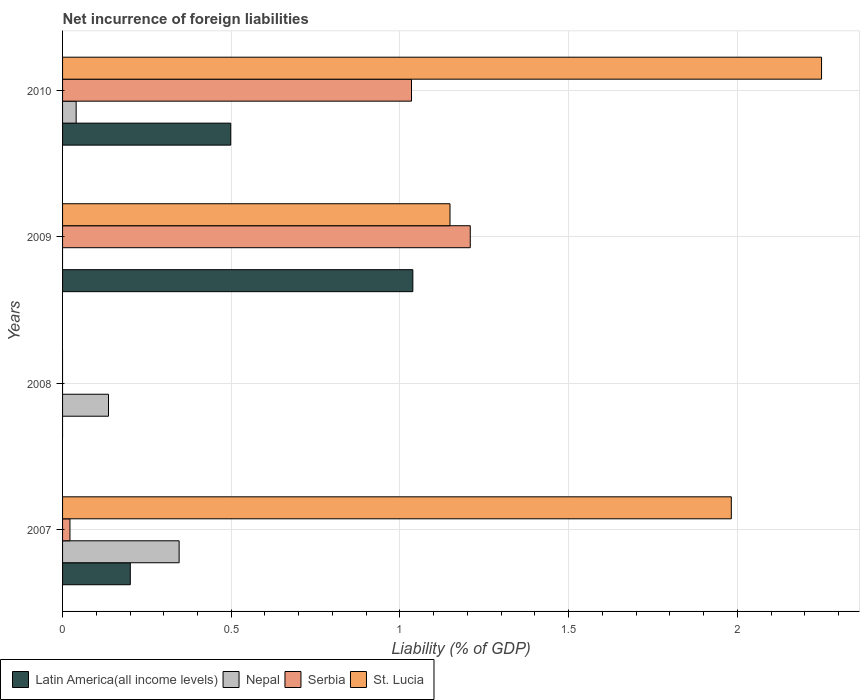Are the number of bars on each tick of the Y-axis equal?
Provide a succinct answer. No. What is the label of the 2nd group of bars from the top?
Your answer should be very brief. 2009. What is the net incurrence of foreign liabilities in Serbia in 2010?
Your answer should be compact. 1.03. Across all years, what is the maximum net incurrence of foreign liabilities in Nepal?
Give a very brief answer. 0.35. What is the total net incurrence of foreign liabilities in Nepal in the graph?
Ensure brevity in your answer.  0.52. What is the difference between the net incurrence of foreign liabilities in St. Lucia in 2007 and that in 2009?
Your answer should be compact. 0.83. What is the difference between the net incurrence of foreign liabilities in Nepal in 2009 and the net incurrence of foreign liabilities in Serbia in 2007?
Give a very brief answer. -0.02. What is the average net incurrence of foreign liabilities in Serbia per year?
Provide a short and direct response. 0.57. In the year 2007, what is the difference between the net incurrence of foreign liabilities in Serbia and net incurrence of foreign liabilities in St. Lucia?
Offer a very short reply. -1.96. In how many years, is the net incurrence of foreign liabilities in Nepal greater than 0.6 %?
Offer a terse response. 0. Is the difference between the net incurrence of foreign liabilities in Serbia in 2007 and 2010 greater than the difference between the net incurrence of foreign liabilities in St. Lucia in 2007 and 2010?
Keep it short and to the point. No. What is the difference between the highest and the second highest net incurrence of foreign liabilities in Serbia?
Your response must be concise. 0.17. What is the difference between the highest and the lowest net incurrence of foreign liabilities in Latin America(all income levels)?
Make the answer very short. 1.04. Is the sum of the net incurrence of foreign liabilities in Serbia in 2009 and 2010 greater than the maximum net incurrence of foreign liabilities in St. Lucia across all years?
Your response must be concise. No. Is it the case that in every year, the sum of the net incurrence of foreign liabilities in Nepal and net incurrence of foreign liabilities in Serbia is greater than the sum of net incurrence of foreign liabilities in Latin America(all income levels) and net incurrence of foreign liabilities in St. Lucia?
Ensure brevity in your answer.  No. Is it the case that in every year, the sum of the net incurrence of foreign liabilities in St. Lucia and net incurrence of foreign liabilities in Serbia is greater than the net incurrence of foreign liabilities in Latin America(all income levels)?
Keep it short and to the point. No. Are the values on the major ticks of X-axis written in scientific E-notation?
Ensure brevity in your answer.  No. Does the graph contain any zero values?
Your answer should be very brief. Yes. Does the graph contain grids?
Keep it short and to the point. Yes. How many legend labels are there?
Your response must be concise. 4. How are the legend labels stacked?
Your response must be concise. Horizontal. What is the title of the graph?
Offer a very short reply. Net incurrence of foreign liabilities. What is the label or title of the X-axis?
Ensure brevity in your answer.  Liability (% of GDP). What is the label or title of the Y-axis?
Your response must be concise. Years. What is the Liability (% of GDP) in Latin America(all income levels) in 2007?
Your response must be concise. 0.2. What is the Liability (% of GDP) of Nepal in 2007?
Provide a succinct answer. 0.35. What is the Liability (% of GDP) in Serbia in 2007?
Offer a terse response. 0.02. What is the Liability (% of GDP) of St. Lucia in 2007?
Your answer should be compact. 1.98. What is the Liability (% of GDP) in Nepal in 2008?
Your answer should be compact. 0.14. What is the Liability (% of GDP) in Serbia in 2008?
Make the answer very short. 0. What is the Liability (% of GDP) in St. Lucia in 2008?
Your answer should be very brief. 0. What is the Liability (% of GDP) of Latin America(all income levels) in 2009?
Offer a terse response. 1.04. What is the Liability (% of GDP) of Nepal in 2009?
Ensure brevity in your answer.  0. What is the Liability (% of GDP) in Serbia in 2009?
Offer a very short reply. 1.21. What is the Liability (% of GDP) of St. Lucia in 2009?
Ensure brevity in your answer.  1.15. What is the Liability (% of GDP) of Latin America(all income levels) in 2010?
Your response must be concise. 0.5. What is the Liability (% of GDP) of Nepal in 2010?
Give a very brief answer. 0.04. What is the Liability (% of GDP) in Serbia in 2010?
Your answer should be very brief. 1.03. What is the Liability (% of GDP) in St. Lucia in 2010?
Your answer should be very brief. 2.25. Across all years, what is the maximum Liability (% of GDP) of Latin America(all income levels)?
Your answer should be very brief. 1.04. Across all years, what is the maximum Liability (% of GDP) of Nepal?
Ensure brevity in your answer.  0.35. Across all years, what is the maximum Liability (% of GDP) in Serbia?
Give a very brief answer. 1.21. Across all years, what is the maximum Liability (% of GDP) of St. Lucia?
Your answer should be very brief. 2.25. Across all years, what is the minimum Liability (% of GDP) in Latin America(all income levels)?
Offer a very short reply. 0. Across all years, what is the minimum Liability (% of GDP) of Serbia?
Your answer should be compact. 0. Across all years, what is the minimum Liability (% of GDP) in St. Lucia?
Your response must be concise. 0. What is the total Liability (% of GDP) in Latin America(all income levels) in the graph?
Keep it short and to the point. 1.74. What is the total Liability (% of GDP) in Nepal in the graph?
Provide a succinct answer. 0.52. What is the total Liability (% of GDP) of Serbia in the graph?
Keep it short and to the point. 2.26. What is the total Liability (% of GDP) of St. Lucia in the graph?
Offer a very short reply. 5.38. What is the difference between the Liability (% of GDP) of Nepal in 2007 and that in 2008?
Your answer should be very brief. 0.21. What is the difference between the Liability (% of GDP) of Latin America(all income levels) in 2007 and that in 2009?
Ensure brevity in your answer.  -0.84. What is the difference between the Liability (% of GDP) of Serbia in 2007 and that in 2009?
Offer a very short reply. -1.19. What is the difference between the Liability (% of GDP) of St. Lucia in 2007 and that in 2009?
Your answer should be very brief. 0.83. What is the difference between the Liability (% of GDP) of Latin America(all income levels) in 2007 and that in 2010?
Offer a very short reply. -0.3. What is the difference between the Liability (% of GDP) of Nepal in 2007 and that in 2010?
Your answer should be compact. 0.31. What is the difference between the Liability (% of GDP) in Serbia in 2007 and that in 2010?
Provide a succinct answer. -1.01. What is the difference between the Liability (% of GDP) of St. Lucia in 2007 and that in 2010?
Offer a terse response. -0.27. What is the difference between the Liability (% of GDP) in Nepal in 2008 and that in 2010?
Your answer should be compact. 0.1. What is the difference between the Liability (% of GDP) of Latin America(all income levels) in 2009 and that in 2010?
Provide a succinct answer. 0.54. What is the difference between the Liability (% of GDP) of Serbia in 2009 and that in 2010?
Provide a short and direct response. 0.17. What is the difference between the Liability (% of GDP) of St. Lucia in 2009 and that in 2010?
Keep it short and to the point. -1.1. What is the difference between the Liability (% of GDP) in Latin America(all income levels) in 2007 and the Liability (% of GDP) in Nepal in 2008?
Keep it short and to the point. 0.06. What is the difference between the Liability (% of GDP) in Latin America(all income levels) in 2007 and the Liability (% of GDP) in Serbia in 2009?
Provide a short and direct response. -1.01. What is the difference between the Liability (% of GDP) of Latin America(all income levels) in 2007 and the Liability (% of GDP) of St. Lucia in 2009?
Your response must be concise. -0.95. What is the difference between the Liability (% of GDP) in Nepal in 2007 and the Liability (% of GDP) in Serbia in 2009?
Your answer should be very brief. -0.86. What is the difference between the Liability (% of GDP) in Nepal in 2007 and the Liability (% of GDP) in St. Lucia in 2009?
Give a very brief answer. -0.8. What is the difference between the Liability (% of GDP) of Serbia in 2007 and the Liability (% of GDP) of St. Lucia in 2009?
Offer a terse response. -1.13. What is the difference between the Liability (% of GDP) in Latin America(all income levels) in 2007 and the Liability (% of GDP) in Nepal in 2010?
Ensure brevity in your answer.  0.16. What is the difference between the Liability (% of GDP) in Latin America(all income levels) in 2007 and the Liability (% of GDP) in Serbia in 2010?
Your answer should be very brief. -0.83. What is the difference between the Liability (% of GDP) in Latin America(all income levels) in 2007 and the Liability (% of GDP) in St. Lucia in 2010?
Offer a terse response. -2.05. What is the difference between the Liability (% of GDP) of Nepal in 2007 and the Liability (% of GDP) of Serbia in 2010?
Make the answer very short. -0.69. What is the difference between the Liability (% of GDP) of Nepal in 2007 and the Liability (% of GDP) of St. Lucia in 2010?
Ensure brevity in your answer.  -1.9. What is the difference between the Liability (% of GDP) of Serbia in 2007 and the Liability (% of GDP) of St. Lucia in 2010?
Provide a succinct answer. -2.23. What is the difference between the Liability (% of GDP) in Nepal in 2008 and the Liability (% of GDP) in Serbia in 2009?
Keep it short and to the point. -1.07. What is the difference between the Liability (% of GDP) of Nepal in 2008 and the Liability (% of GDP) of St. Lucia in 2009?
Ensure brevity in your answer.  -1.01. What is the difference between the Liability (% of GDP) in Nepal in 2008 and the Liability (% of GDP) in Serbia in 2010?
Make the answer very short. -0.9. What is the difference between the Liability (% of GDP) of Nepal in 2008 and the Liability (% of GDP) of St. Lucia in 2010?
Provide a short and direct response. -2.11. What is the difference between the Liability (% of GDP) in Latin America(all income levels) in 2009 and the Liability (% of GDP) in Nepal in 2010?
Your answer should be very brief. 1. What is the difference between the Liability (% of GDP) of Latin America(all income levels) in 2009 and the Liability (% of GDP) of Serbia in 2010?
Provide a short and direct response. 0. What is the difference between the Liability (% of GDP) in Latin America(all income levels) in 2009 and the Liability (% of GDP) in St. Lucia in 2010?
Provide a succinct answer. -1.21. What is the difference between the Liability (% of GDP) in Serbia in 2009 and the Liability (% of GDP) in St. Lucia in 2010?
Your response must be concise. -1.04. What is the average Liability (% of GDP) of Latin America(all income levels) per year?
Offer a very short reply. 0.43. What is the average Liability (% of GDP) of Nepal per year?
Make the answer very short. 0.13. What is the average Liability (% of GDP) of Serbia per year?
Provide a short and direct response. 0.57. What is the average Liability (% of GDP) of St. Lucia per year?
Make the answer very short. 1.35. In the year 2007, what is the difference between the Liability (% of GDP) of Latin America(all income levels) and Liability (% of GDP) of Nepal?
Your response must be concise. -0.14. In the year 2007, what is the difference between the Liability (% of GDP) in Latin America(all income levels) and Liability (% of GDP) in Serbia?
Provide a succinct answer. 0.18. In the year 2007, what is the difference between the Liability (% of GDP) of Latin America(all income levels) and Liability (% of GDP) of St. Lucia?
Offer a terse response. -1.78. In the year 2007, what is the difference between the Liability (% of GDP) of Nepal and Liability (% of GDP) of Serbia?
Keep it short and to the point. 0.32. In the year 2007, what is the difference between the Liability (% of GDP) of Nepal and Liability (% of GDP) of St. Lucia?
Make the answer very short. -1.64. In the year 2007, what is the difference between the Liability (% of GDP) of Serbia and Liability (% of GDP) of St. Lucia?
Your response must be concise. -1.96. In the year 2009, what is the difference between the Liability (% of GDP) of Latin America(all income levels) and Liability (% of GDP) of Serbia?
Offer a very short reply. -0.17. In the year 2009, what is the difference between the Liability (% of GDP) of Latin America(all income levels) and Liability (% of GDP) of St. Lucia?
Give a very brief answer. -0.11. In the year 2009, what is the difference between the Liability (% of GDP) of Serbia and Liability (% of GDP) of St. Lucia?
Your answer should be very brief. 0.06. In the year 2010, what is the difference between the Liability (% of GDP) of Latin America(all income levels) and Liability (% of GDP) of Nepal?
Ensure brevity in your answer.  0.46. In the year 2010, what is the difference between the Liability (% of GDP) of Latin America(all income levels) and Liability (% of GDP) of Serbia?
Provide a short and direct response. -0.54. In the year 2010, what is the difference between the Liability (% of GDP) of Latin America(all income levels) and Liability (% of GDP) of St. Lucia?
Offer a terse response. -1.75. In the year 2010, what is the difference between the Liability (% of GDP) of Nepal and Liability (% of GDP) of Serbia?
Provide a succinct answer. -0.99. In the year 2010, what is the difference between the Liability (% of GDP) in Nepal and Liability (% of GDP) in St. Lucia?
Your response must be concise. -2.21. In the year 2010, what is the difference between the Liability (% of GDP) in Serbia and Liability (% of GDP) in St. Lucia?
Provide a succinct answer. -1.22. What is the ratio of the Liability (% of GDP) of Nepal in 2007 to that in 2008?
Offer a very short reply. 2.54. What is the ratio of the Liability (% of GDP) of Latin America(all income levels) in 2007 to that in 2009?
Provide a short and direct response. 0.19. What is the ratio of the Liability (% of GDP) in Serbia in 2007 to that in 2009?
Provide a succinct answer. 0.02. What is the ratio of the Liability (% of GDP) of St. Lucia in 2007 to that in 2009?
Make the answer very short. 1.73. What is the ratio of the Liability (% of GDP) of Latin America(all income levels) in 2007 to that in 2010?
Offer a terse response. 0.4. What is the ratio of the Liability (% of GDP) in Nepal in 2007 to that in 2010?
Your answer should be compact. 8.58. What is the ratio of the Liability (% of GDP) in Serbia in 2007 to that in 2010?
Offer a terse response. 0.02. What is the ratio of the Liability (% of GDP) in St. Lucia in 2007 to that in 2010?
Your answer should be compact. 0.88. What is the ratio of the Liability (% of GDP) in Nepal in 2008 to that in 2010?
Your response must be concise. 3.38. What is the ratio of the Liability (% of GDP) in Latin America(all income levels) in 2009 to that in 2010?
Offer a very short reply. 2.08. What is the ratio of the Liability (% of GDP) in Serbia in 2009 to that in 2010?
Ensure brevity in your answer.  1.17. What is the ratio of the Liability (% of GDP) in St. Lucia in 2009 to that in 2010?
Offer a very short reply. 0.51. What is the difference between the highest and the second highest Liability (% of GDP) in Latin America(all income levels)?
Give a very brief answer. 0.54. What is the difference between the highest and the second highest Liability (% of GDP) in Nepal?
Your answer should be very brief. 0.21. What is the difference between the highest and the second highest Liability (% of GDP) in Serbia?
Your response must be concise. 0.17. What is the difference between the highest and the second highest Liability (% of GDP) of St. Lucia?
Keep it short and to the point. 0.27. What is the difference between the highest and the lowest Liability (% of GDP) in Latin America(all income levels)?
Provide a short and direct response. 1.04. What is the difference between the highest and the lowest Liability (% of GDP) in Nepal?
Provide a short and direct response. 0.35. What is the difference between the highest and the lowest Liability (% of GDP) in Serbia?
Your response must be concise. 1.21. What is the difference between the highest and the lowest Liability (% of GDP) in St. Lucia?
Provide a succinct answer. 2.25. 